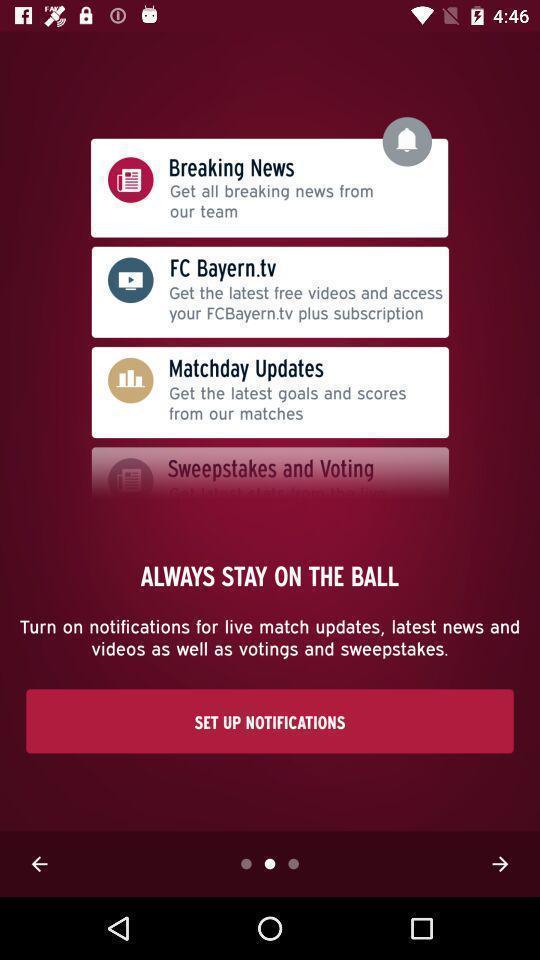Give me a summary of this screen capture. Welcome page displaying to set up notifications. 